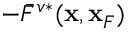Convert formula to latex. <formula><loc_0><loc_0><loc_500><loc_500>- \bar { F } ^ { v * } ( { x } , { x } _ { F } )</formula> 